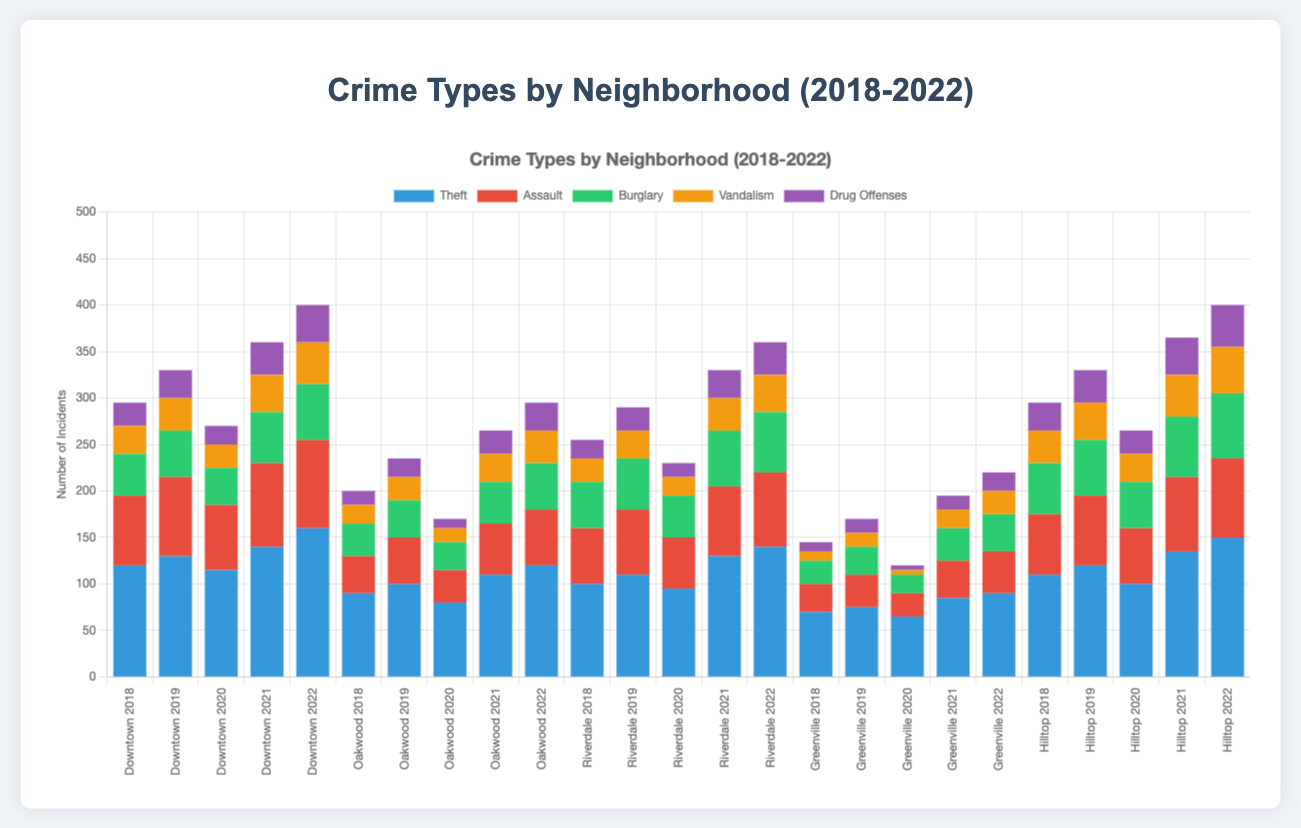Which neighborhood had the highest total number of crimes in 2022? Look at the 2022 section for each neighborhood and sum the crime types. Downtown has 160+95+60+45+40=400; Oakwood has 120+60+50+35+30=295; Riverdale has 140+80+65+40+35=360; Greenville has 90+45+40+25+20=220; Hilltop has 150+85+70+50+45=400. The highest total is 400 in both Downtown and Hilltop.
Answer: Downtown and Hilltop Which type of crime saw the largest increase in Downtown from 2018 to 2022? Compare the total number of each crime type in Downtown for 2018 and 2022 and find the difference. Theft increased by 160-120=40, Assault increased by 95-75=20, Burglary increased by 60-45=15, Vandalism increased by 45-30=15, Drug Offenses increased by 40-25=15. Theft had the largest increase.
Answer: Theft Compare the total number of burglaries in Oakwood and Riverdale in 2021. Which is higher? Extract the number of burglaries in Oakwood and Riverdale in 2021. Oakwood had 45, and Riverdale had 60. 60 in Riverdale is higher.
Answer: Riverdale How did the number of assaults in Greenville change from 2018 to 2020? Extract the number of assaults in Greenville from 2018 to 2020. In 2018 it was 30, and in 2020 it was 25. The change is 30-25=5, so there was a decrease of 5.
Answer: Decreased by 5 What is the total number of vandalism incidents across all neighborhoods in 2020? Sum the number of vandalism incidents for all neighborhoods in 2020. Downtown has 25, Oakwood has 15, Riverdale has 20, Greenville has 5, and Hilltop has 30. The total is 25+15+20+5+30=95.
Answer: 95 In which year did Hilltop have the fewest total crimes? Sum the total number of crimes in Hilltop for each year and compare. 2018: 110+65+55+35+30=295, 2019: 120+75+60+40+35=330, 2020: 100+60+50+30+25=265, 2021: 135+80+65+45+40=365, 2022: 150+85+70+50+45=400. The fewest total is 265 in 2020.
Answer: 2020 Which neighborhood had the highest number of drug offenses in any single year? Compare the number of drug offenses for each neighborhood across all years. Downtown has the highest with 2022's 40, Oakwood has 30 in 2022, Riverdale has 35 in 2022, Greenville has 20 in 2022, and Hilltop has 45 in 2022. The highest single year number is 45 in Hilltop, 2022.
Answer: Hilltop How does the total number of thefts in 2022 across all neighborhoods compare to the total number in 2018? Sum the number of thefts in all neighborhoods for 2022 and 2018. 2022: 160+120+140+90+150=660, 2018: 120+90+100+70+110=490. Comparison is 660-490=170 more in 2022.
Answer: 170 more in 2022 Which neighborhood had the most consistent levels of assault from 2018 to 2022? Compare the assault numbers for each neighborhood over the years for consistency. Calculate the range (highest value minus lowest value). Downtown: 95-70=25, Oakwood: 60-35=25, Riverdale: 80-55=25, Greenville: 45-25=20, Hilltop: 85-65=20. Greenville and Hilltop have the smallest range.
Answer: Greenville and Hilltop What was the trend in vandalism incidents in Riverdale from 2018 to 2022? Extract the number of vandalism incidents in Riverdale from 2018 to 2022. 2018: 25, 2019: 30, 2020: 20, 2021: 35, 2022: 40. The trend shows an initial decrease, then an increase.
Answer: Initial decrease, then increase 